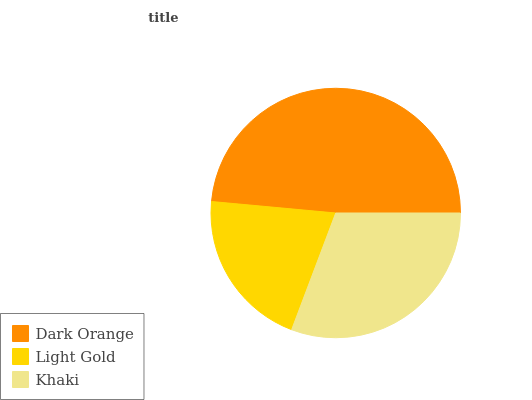Is Light Gold the minimum?
Answer yes or no. Yes. Is Dark Orange the maximum?
Answer yes or no. Yes. Is Khaki the minimum?
Answer yes or no. No. Is Khaki the maximum?
Answer yes or no. No. Is Khaki greater than Light Gold?
Answer yes or no. Yes. Is Light Gold less than Khaki?
Answer yes or no. Yes. Is Light Gold greater than Khaki?
Answer yes or no. No. Is Khaki less than Light Gold?
Answer yes or no. No. Is Khaki the high median?
Answer yes or no. Yes. Is Khaki the low median?
Answer yes or no. Yes. Is Dark Orange the high median?
Answer yes or no. No. Is Dark Orange the low median?
Answer yes or no. No. 